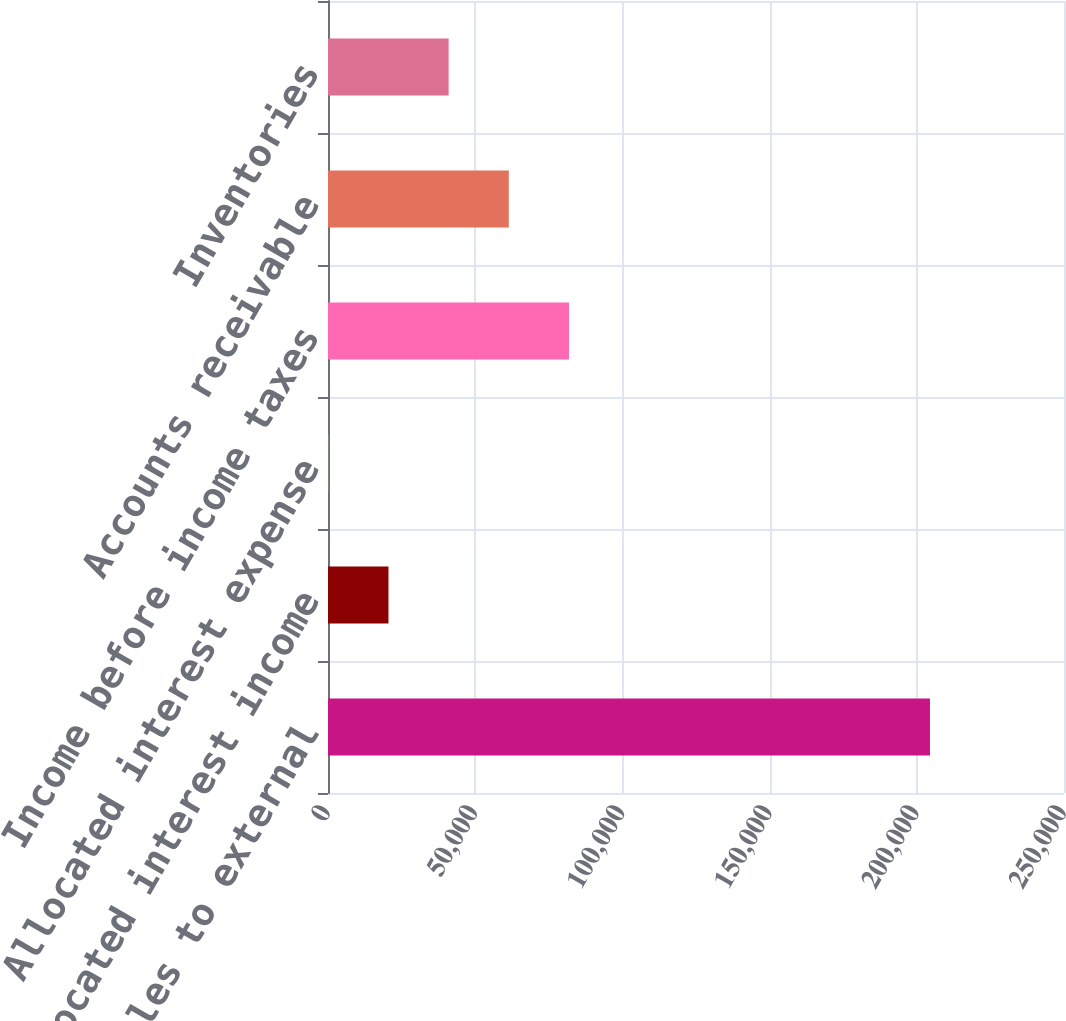<chart> <loc_0><loc_0><loc_500><loc_500><bar_chart><fcel>Net sales to external<fcel>Allocated interest income<fcel>Allocated interest expense<fcel>Income before income taxes<fcel>Accounts receivable<fcel>Inventories<nl><fcel>204477<fcel>20541.3<fcel>104<fcel>81853.2<fcel>61415.9<fcel>40978.6<nl></chart> 